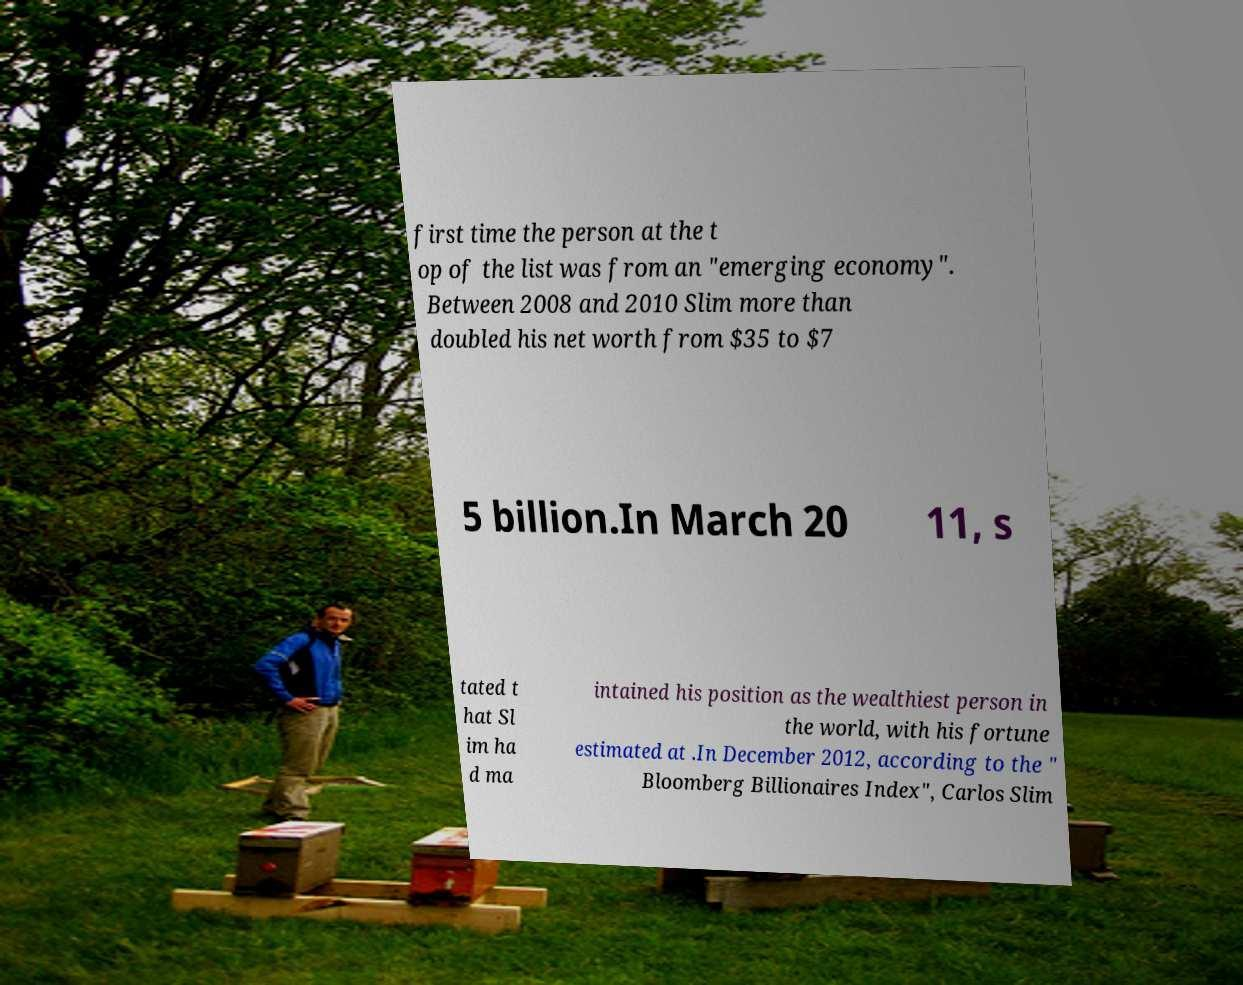Can you accurately transcribe the text from the provided image for me? first time the person at the t op of the list was from an "emerging economy". Between 2008 and 2010 Slim more than doubled his net worth from $35 to $7 5 billion.In March 20 11, s tated t hat Sl im ha d ma intained his position as the wealthiest person in the world, with his fortune estimated at .In December 2012, according to the " Bloomberg Billionaires Index", Carlos Slim 